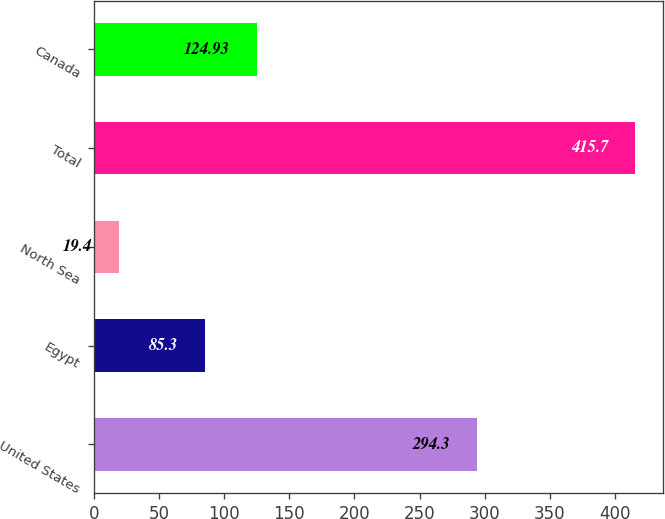Convert chart. <chart><loc_0><loc_0><loc_500><loc_500><bar_chart><fcel>United States<fcel>Egypt<fcel>North Sea<fcel>Total<fcel>Canada<nl><fcel>294.3<fcel>85.3<fcel>19.4<fcel>415.7<fcel>124.93<nl></chart> 